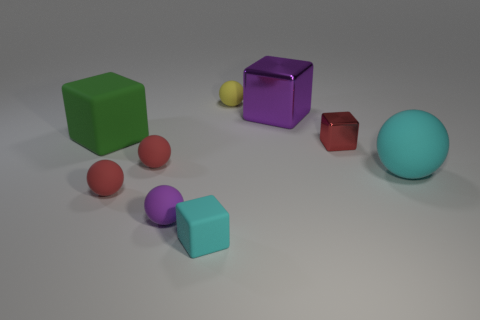How many red spheres must be subtracted to get 1 red spheres? 1 Subtract all cyan blocks. How many red balls are left? 2 Subtract 1 cubes. How many cubes are left? 3 Subtract all red shiny cubes. How many cubes are left? 3 Subtract all purple cubes. How many cubes are left? 3 Subtract all blocks. How many objects are left? 5 Subtract all purple cubes. Subtract all cyan balls. How many cubes are left? 3 Subtract all big gray matte things. Subtract all small red balls. How many objects are left? 7 Add 3 cyan matte cubes. How many cyan matte cubes are left? 4 Add 9 cyan blocks. How many cyan blocks exist? 10 